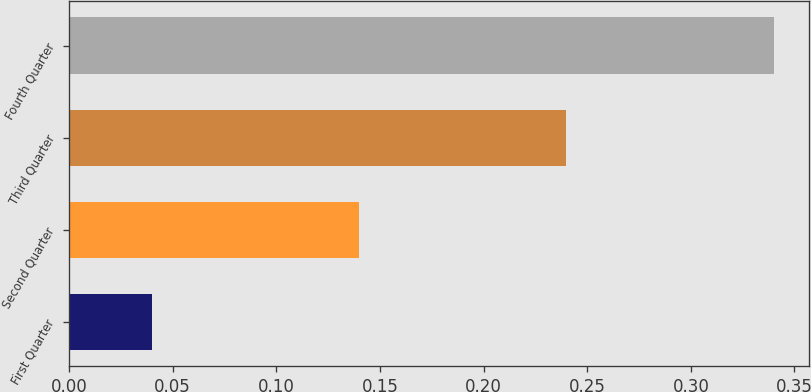<chart> <loc_0><loc_0><loc_500><loc_500><bar_chart><fcel>First Quarter<fcel>Second Quarter<fcel>Third Quarter<fcel>Fourth Quarter<nl><fcel>0.04<fcel>0.14<fcel>0.24<fcel>0.34<nl></chart> 